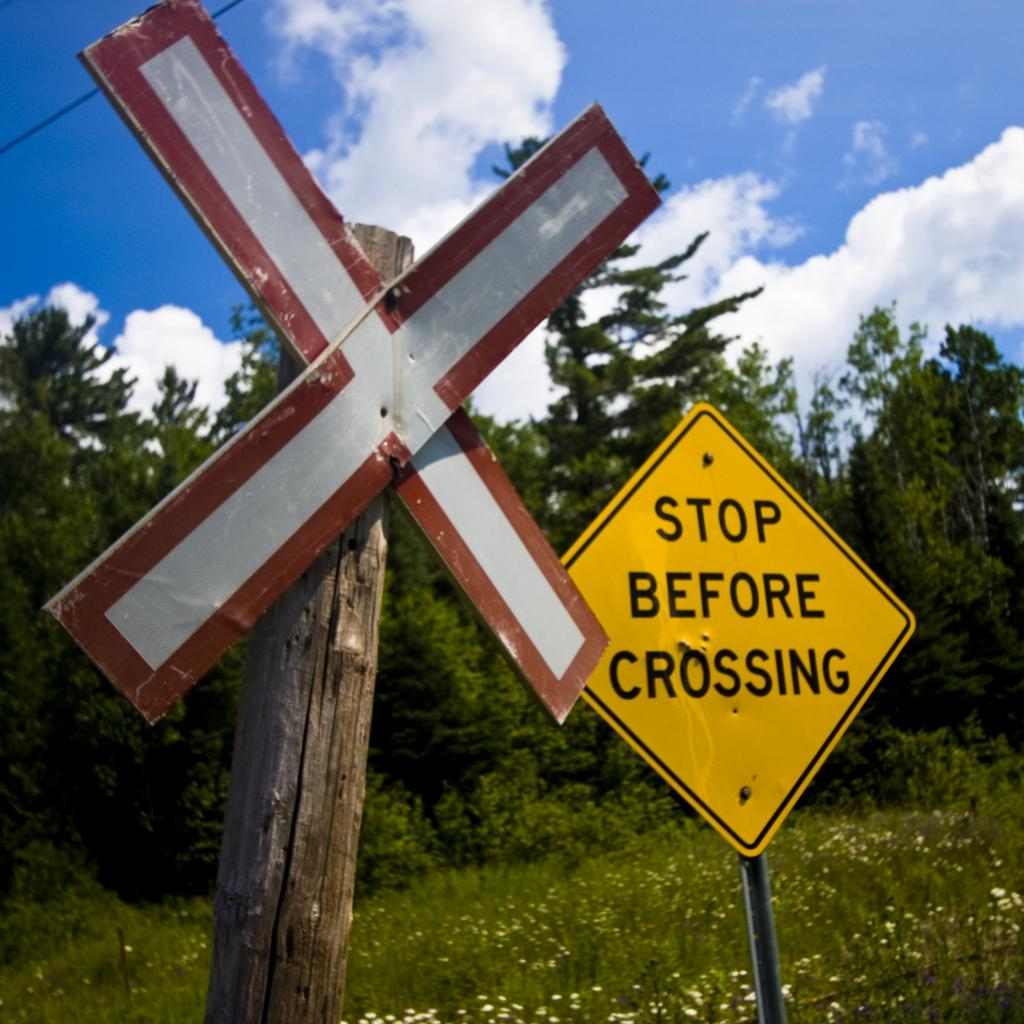Provide a one-sentence caption for the provided image. a street sign that is labeled 'stop before crossing'. 